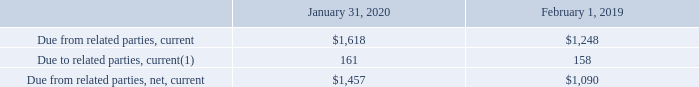Due To/From Related Parties, Net
Amounts due to and from related parties, net as of the periods presented consisted of the following (table in millions):
(1) Includes an immaterial amount related to the Company’s current operating lease liabilities due to related parties as of January 31, 2020.
The Company also recognized an immaterial amount related to non-current operating lease liabilities due to related parties. This amount has been included in operating lease liabilities on the consolidated balance sheet as of January 31, 2020.
What did the current amounts due to related parties include? An immaterial amount related to the company’s current operating lease liabilities due to related parties as of january 31, 2020. What was the current amount due from related parties in 2019?
Answer scale should be: million. 1,248. Which years does the table provide information for net Amounts due to and from related parties? 2020, 2019. How many years did current amount due from related parties exceed $1,000 million? 2020##2019
Answer: 2. What was the change in current amount due to related parties between 2019 and 2020?
Answer scale should be: million. 161-158
Answer: 3. What was the percentage change in the net current amount due from related parities between 2019 and 2020?
Answer scale should be: percent. (1,457-1,090)/1,090
Answer: 33.67. Due To/From Related Parties, Net
Amounts due to and from related parties, net as of the periods presented consisted of the following (table in millions):
(1) Includes an immaterial amount related to our current operating lease liabilities due to related parties as of January 31, 2020.
We also recognized an immaterial amount related to non-current operating lease liabilities due to related parties. This amount has been included in operating lease liabilities on the consolidated balance sheet as of January 31, 2020.
Amounts included in due from related parties, net, excluding DFS and tax obligations, includes the current portion of amounts due to and due from related parties. Amounts included in due from related parties, net are generally settled in cash within 60 days of each quarter-end.
What did amounts due to related parties, current include? An immaterial amount related to our current operating lease liabilities due to related parties as of january 31, 2020. What was the amount due to related parties, current in 2020?
Answer scale should be: million. 161. What was the amount due from related parties, net, current in 2019?
Answer scale should be: million. 1,090. What was the change in the current amount due from related parties between 2019 and 2020?
Answer scale should be: million. 1,618-1,248
Answer: 370. How many years did current amounts due to related parties exceed $100 million? 2020##2019
Answer: 2. What was the percentage change in the current net amount due from related parties between 2019 and 2020?
Answer scale should be: percent. (1,457-1,090)/1,090
Answer: 33.67. 